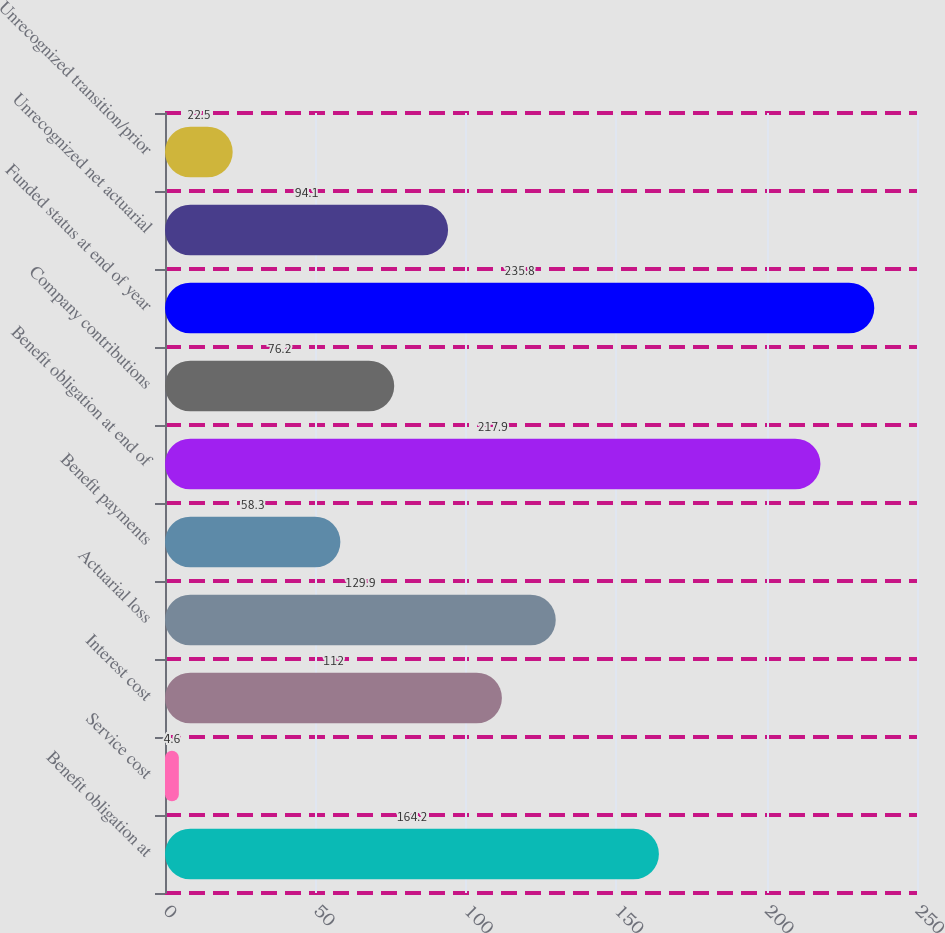Convert chart to OTSL. <chart><loc_0><loc_0><loc_500><loc_500><bar_chart><fcel>Benefit obligation at<fcel>Service cost<fcel>Interest cost<fcel>Actuarial loss<fcel>Benefit payments<fcel>Benefit obligation at end of<fcel>Company contributions<fcel>Funded status at end of year<fcel>Unrecognized net actuarial<fcel>Unrecognized transition/prior<nl><fcel>164.2<fcel>4.6<fcel>112<fcel>129.9<fcel>58.3<fcel>217.9<fcel>76.2<fcel>235.8<fcel>94.1<fcel>22.5<nl></chart> 